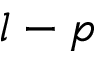<formula> <loc_0><loc_0><loc_500><loc_500>l - p</formula> 